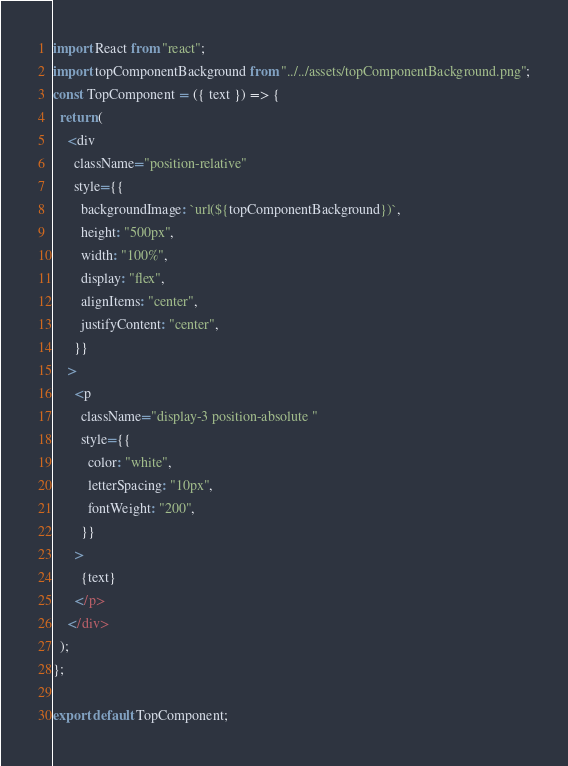Convert code to text. <code><loc_0><loc_0><loc_500><loc_500><_JavaScript_>import React from "react";
import topComponentBackground from "../../assets/topComponentBackground.png";
const TopComponent = ({ text }) => {
  return (
    <div
      className="position-relative"
      style={{
        backgroundImage: `url(${topComponentBackground})`,
        height: "500px",
        width: "100%",
        display: "flex",
        alignItems: "center",
        justifyContent: "center",
      }}
    >
      <p
        className="display-3 position-absolute "
        style={{
          color: "white",
          letterSpacing: "10px",
          fontWeight: "200",
        }}
      >
        {text}
      </p>
    </div>
  );
};

export default TopComponent;
</code> 